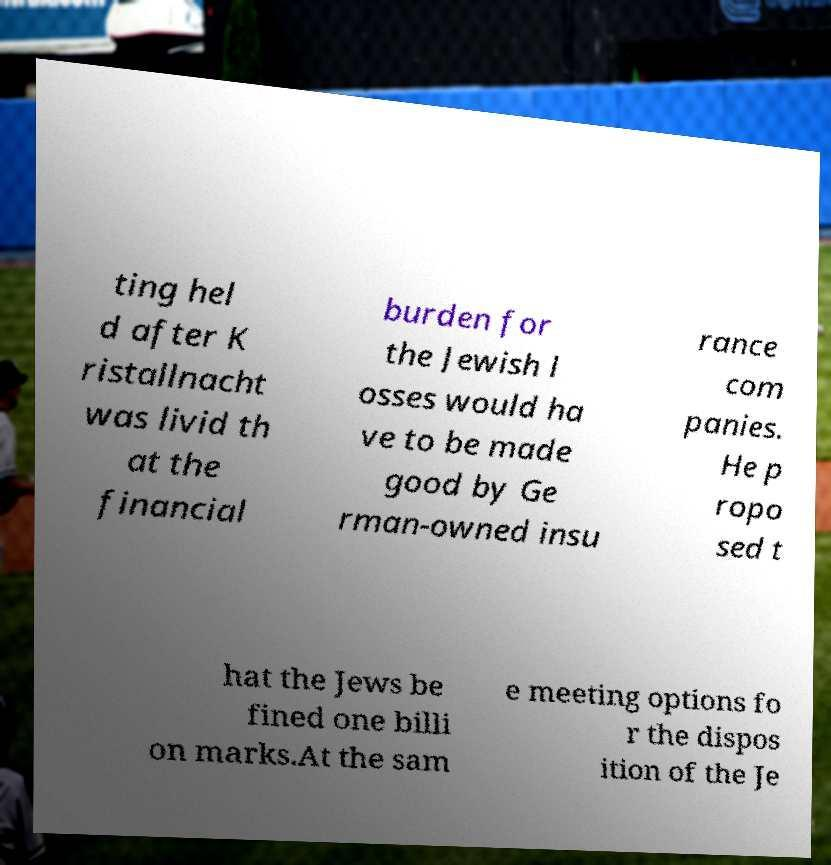Can you accurately transcribe the text from the provided image for me? ting hel d after K ristallnacht was livid th at the financial burden for the Jewish l osses would ha ve to be made good by Ge rman-owned insu rance com panies. He p ropo sed t hat the Jews be fined one billi on marks.At the sam e meeting options fo r the dispos ition of the Je 